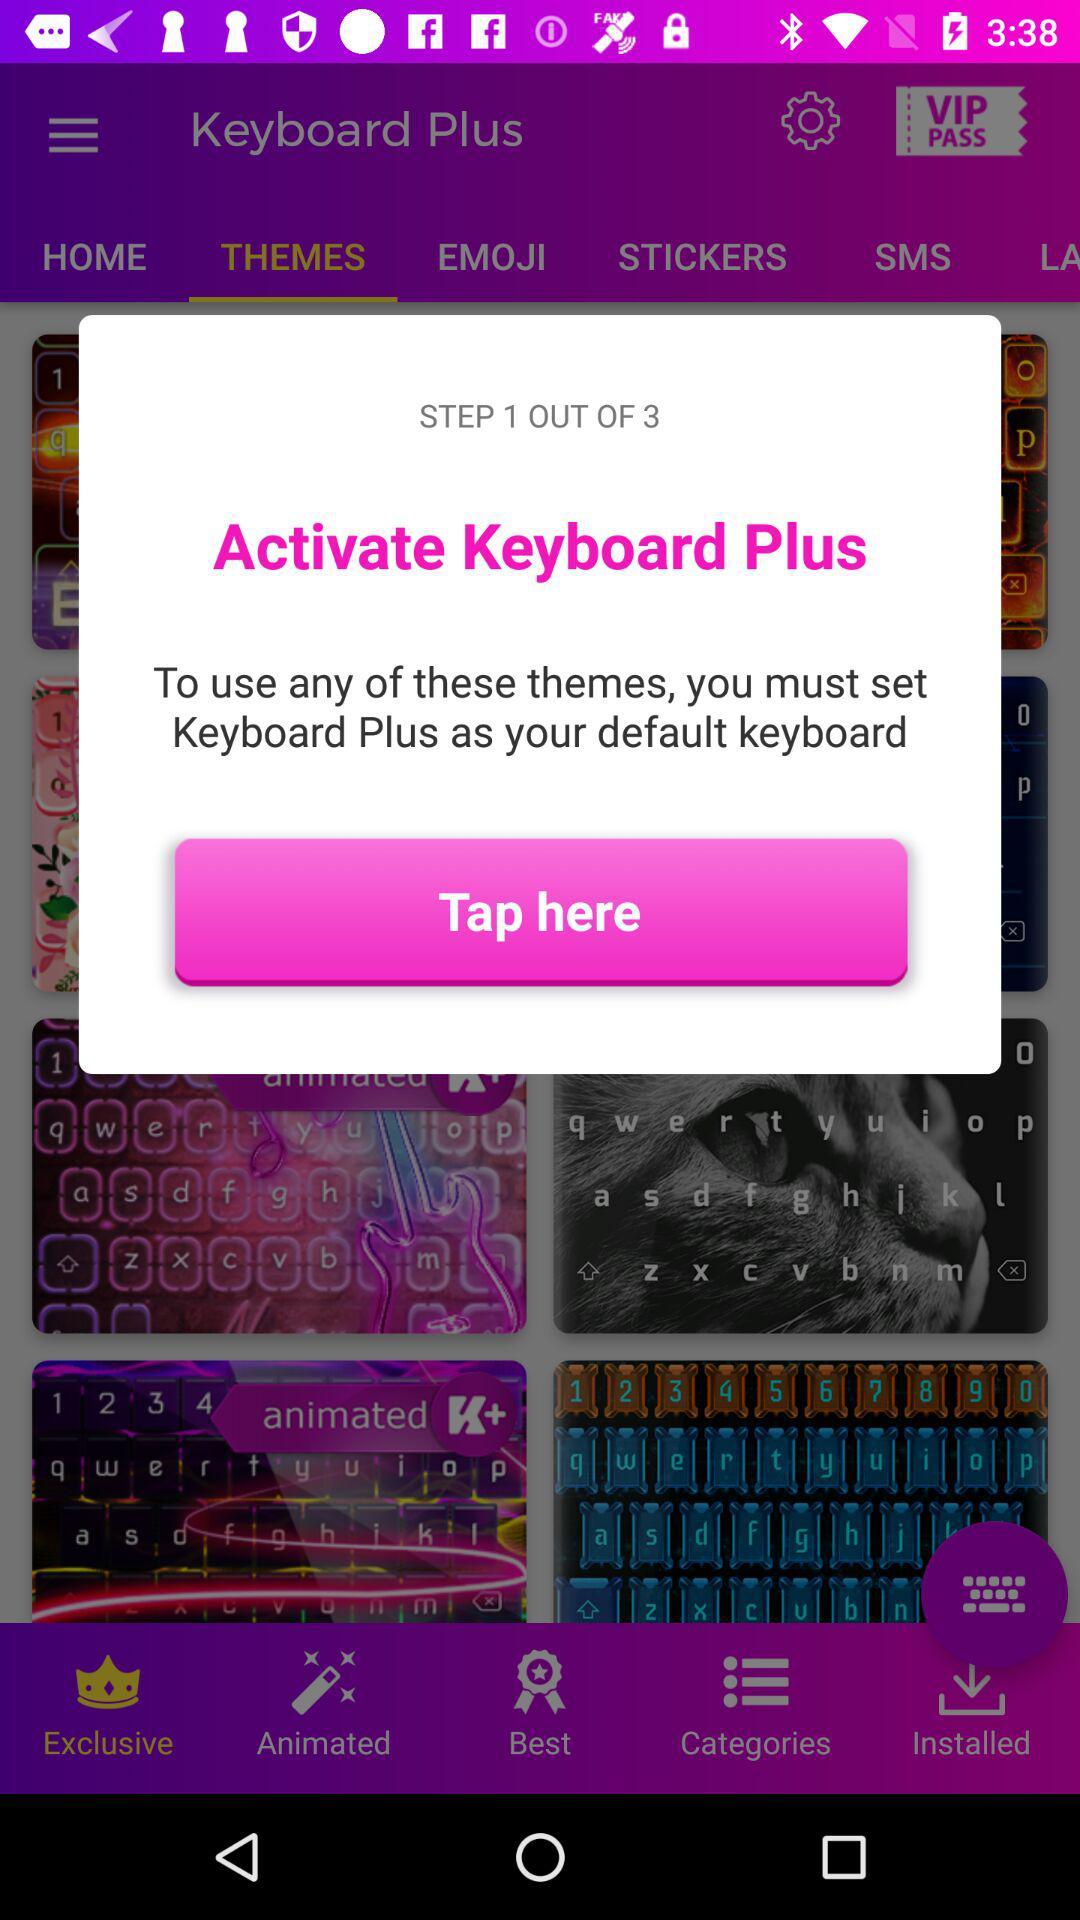How many steps are there in this process?
Answer the question using a single word or phrase. 3 